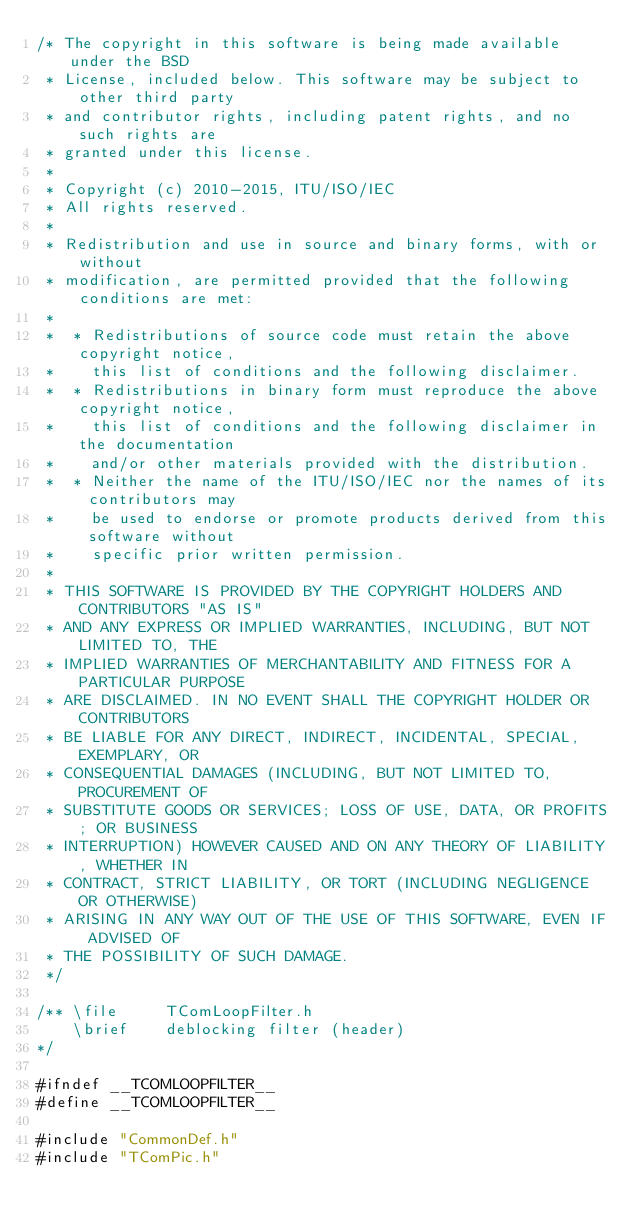Convert code to text. <code><loc_0><loc_0><loc_500><loc_500><_C_>/* The copyright in this software is being made available under the BSD
 * License, included below. This software may be subject to other third party
 * and contributor rights, including patent rights, and no such rights are
 * granted under this license.
 *
 * Copyright (c) 2010-2015, ITU/ISO/IEC
 * All rights reserved.
 *
 * Redistribution and use in source and binary forms, with or without
 * modification, are permitted provided that the following conditions are met:
 *
 *  * Redistributions of source code must retain the above copyright notice,
 *    this list of conditions and the following disclaimer.
 *  * Redistributions in binary form must reproduce the above copyright notice,
 *    this list of conditions and the following disclaimer in the documentation
 *    and/or other materials provided with the distribution.
 *  * Neither the name of the ITU/ISO/IEC nor the names of its contributors may
 *    be used to endorse or promote products derived from this software without
 *    specific prior written permission.
 *
 * THIS SOFTWARE IS PROVIDED BY THE COPYRIGHT HOLDERS AND CONTRIBUTORS "AS IS"
 * AND ANY EXPRESS OR IMPLIED WARRANTIES, INCLUDING, BUT NOT LIMITED TO, THE
 * IMPLIED WARRANTIES OF MERCHANTABILITY AND FITNESS FOR A PARTICULAR PURPOSE
 * ARE DISCLAIMED. IN NO EVENT SHALL THE COPYRIGHT HOLDER OR CONTRIBUTORS
 * BE LIABLE FOR ANY DIRECT, INDIRECT, INCIDENTAL, SPECIAL, EXEMPLARY, OR
 * CONSEQUENTIAL DAMAGES (INCLUDING, BUT NOT LIMITED TO, PROCUREMENT OF
 * SUBSTITUTE GOODS OR SERVICES; LOSS OF USE, DATA, OR PROFITS; OR BUSINESS
 * INTERRUPTION) HOWEVER CAUSED AND ON ANY THEORY OF LIABILITY, WHETHER IN
 * CONTRACT, STRICT LIABILITY, OR TORT (INCLUDING NEGLIGENCE OR OTHERWISE)
 * ARISING IN ANY WAY OUT OF THE USE OF THIS SOFTWARE, EVEN IF ADVISED OF
 * THE POSSIBILITY OF SUCH DAMAGE.
 */

/** \file     TComLoopFilter.h
    \brief    deblocking filter (header)
*/

#ifndef __TCOMLOOPFILTER__
#define __TCOMLOOPFILTER__

#include "CommonDef.h"
#include "TComPic.h"
</code> 